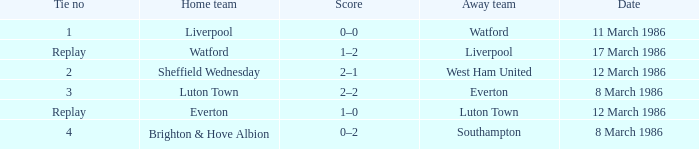What was the tied score in the game involving sheffield wednesday? 2.0. 